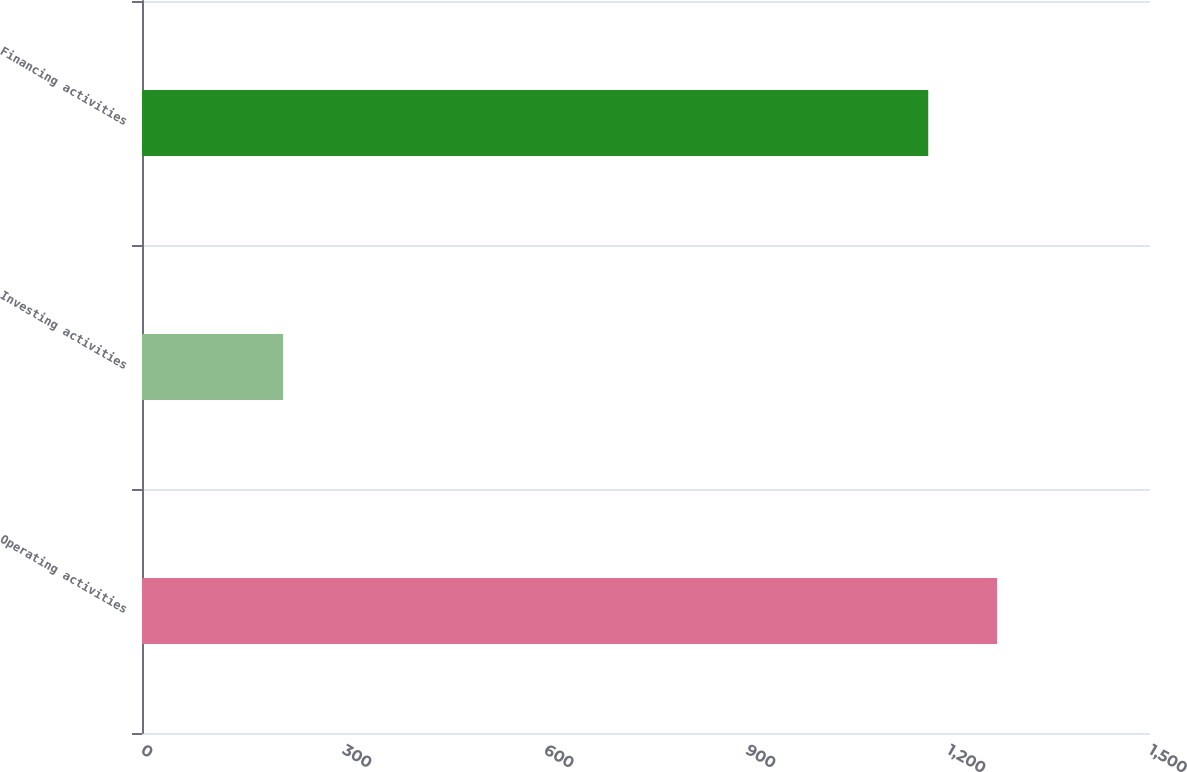<chart> <loc_0><loc_0><loc_500><loc_500><bar_chart><fcel>Operating activities<fcel>Investing activities<fcel>Financing activities<nl><fcel>1272.4<fcel>210<fcel>1170<nl></chart> 